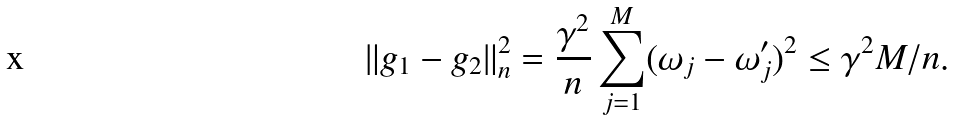<formula> <loc_0><loc_0><loc_500><loc_500>\| g _ { 1 } - g _ { 2 } \| ^ { 2 } _ { n } = \frac { \gamma ^ { 2 } } { n } \sum _ { j = 1 } ^ { M } ( \omega _ { j } - \omega _ { j } ^ { \prime } ) ^ { 2 } \leq \gamma ^ { 2 } M / n .</formula> 